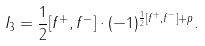Convert formula to latex. <formula><loc_0><loc_0><loc_500><loc_500>I _ { 3 } = \frac { 1 } { 2 } [ f ^ { + } , f ^ { - } ] \cdot ( - 1 ) ^ { \frac { 1 } { 2 } [ f ^ { + } , f ^ { - } ] + p } .</formula> 